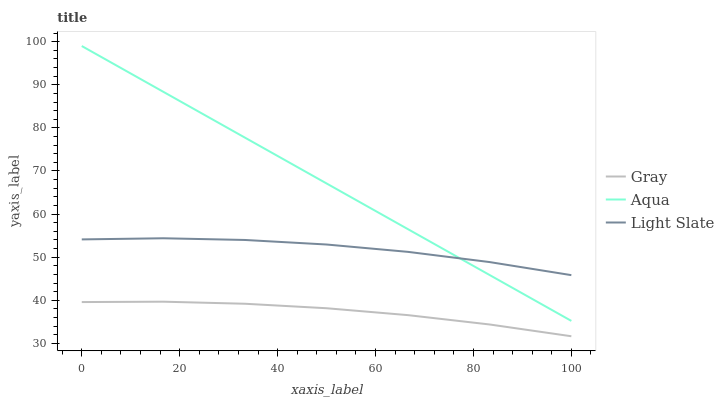Does Gray have the minimum area under the curve?
Answer yes or no. Yes. Does Aqua have the maximum area under the curve?
Answer yes or no. Yes. Does Aqua have the minimum area under the curve?
Answer yes or no. No. Does Gray have the maximum area under the curve?
Answer yes or no. No. Is Aqua the smoothest?
Answer yes or no. Yes. Is Light Slate the roughest?
Answer yes or no. Yes. Is Gray the smoothest?
Answer yes or no. No. Is Gray the roughest?
Answer yes or no. No. Does Gray have the lowest value?
Answer yes or no. Yes. Does Aqua have the lowest value?
Answer yes or no. No. Does Aqua have the highest value?
Answer yes or no. Yes. Does Gray have the highest value?
Answer yes or no. No. Is Gray less than Aqua?
Answer yes or no. Yes. Is Aqua greater than Gray?
Answer yes or no. Yes. Does Light Slate intersect Aqua?
Answer yes or no. Yes. Is Light Slate less than Aqua?
Answer yes or no. No. Is Light Slate greater than Aqua?
Answer yes or no. No. Does Gray intersect Aqua?
Answer yes or no. No. 